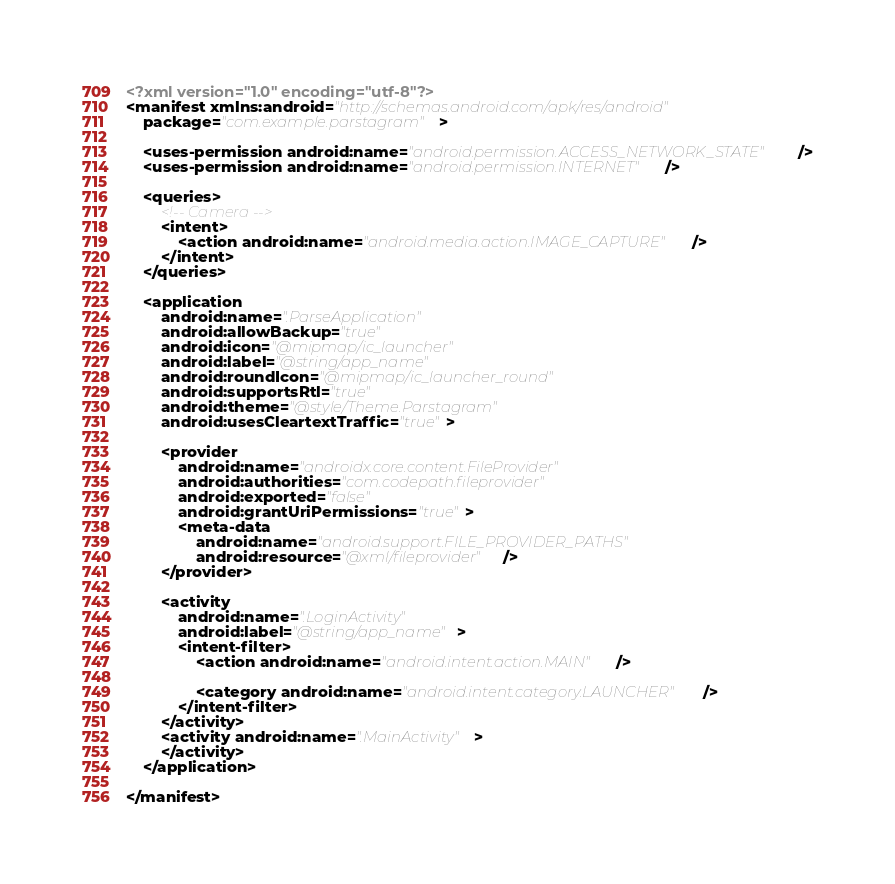Convert code to text. <code><loc_0><loc_0><loc_500><loc_500><_XML_><?xml version="1.0" encoding="utf-8"?>
<manifest xmlns:android="http://schemas.android.com/apk/res/android"
    package="com.example.parstagram">

    <uses-permission android:name="android.permission.ACCESS_NETWORK_STATE" />
    <uses-permission android:name="android.permission.INTERNET" />

    <queries>
        <!-- Camera -->
        <intent>
            <action android:name="android.media.action.IMAGE_CAPTURE" />
        </intent>
    </queries>

    <application
        android:name=".ParseApplication"
        android:allowBackup="true"
        android:icon="@mipmap/ic_launcher"
        android:label="@string/app_name"
        android:roundIcon="@mipmap/ic_launcher_round"
        android:supportsRtl="true"
        android:theme="@style/Theme.Parstagram"
        android:usesCleartextTraffic="true">

        <provider
            android:name="androidx.core.content.FileProvider"
            android:authorities="com.codepath.fileprovider"
            android:exported="false"
            android:grantUriPermissions="true">
            <meta-data
                android:name="android.support.FILE_PROVIDER_PATHS"
                android:resource="@xml/fileprovider" />
        </provider>

        <activity
            android:name=".LoginActivity"
            android:label="@string/app_name">
            <intent-filter>
                <action android:name="android.intent.action.MAIN" />

                <category android:name="android.intent.category.LAUNCHER" />
            </intent-filter>
        </activity>
        <activity android:name=".MainActivity">
        </activity>
    </application>

</manifest></code> 